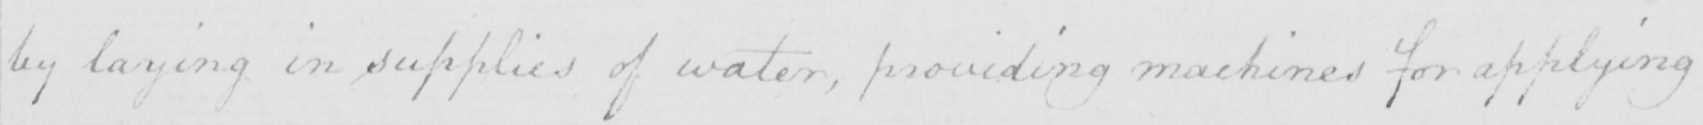Transcribe the text shown in this historical manuscript line. by laying in supplies of water , providing machines for applying 